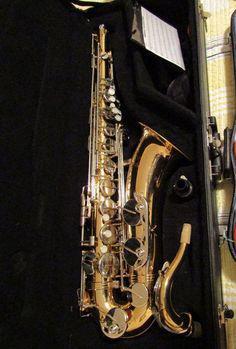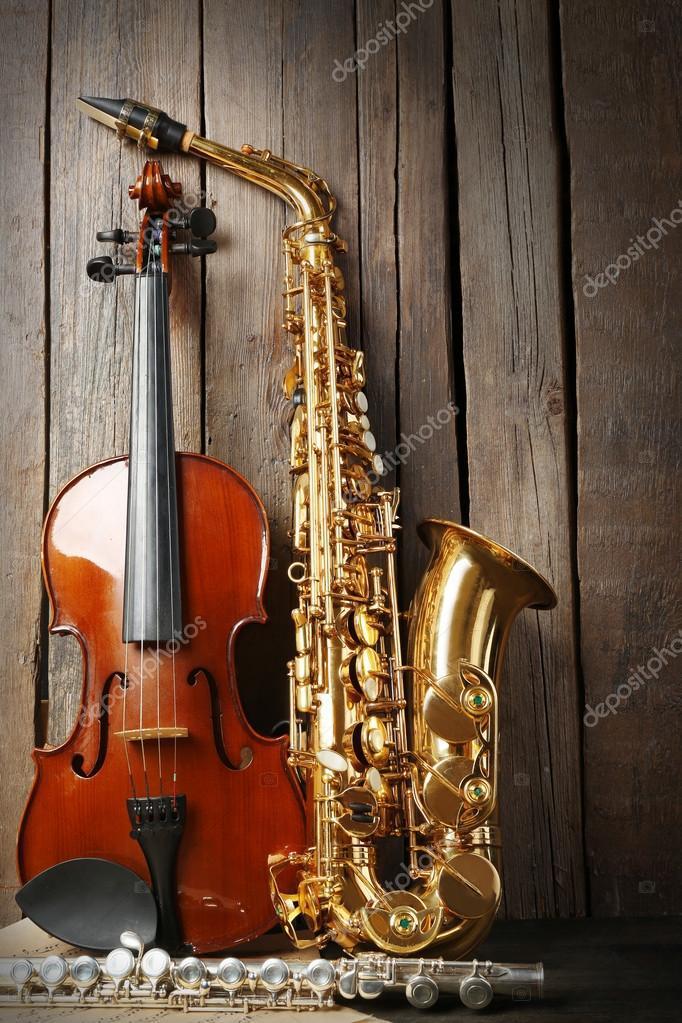The first image is the image on the left, the second image is the image on the right. Given the left and right images, does the statement "An image shows a guitar, a gold saxophone, and a silver clarinet, all standing upright side-by-side." hold true? Answer yes or no. No. 